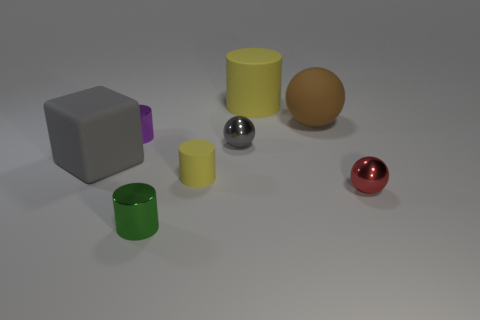Add 2 large gray rubber things. How many objects exist? 10 Subtract all cubes. How many objects are left? 7 Subtract all large blocks. Subtract all large gray matte blocks. How many objects are left? 6 Add 8 green metallic cylinders. How many green metallic cylinders are left? 9 Add 2 big blue objects. How many big blue objects exist? 2 Subtract 1 gray cubes. How many objects are left? 7 